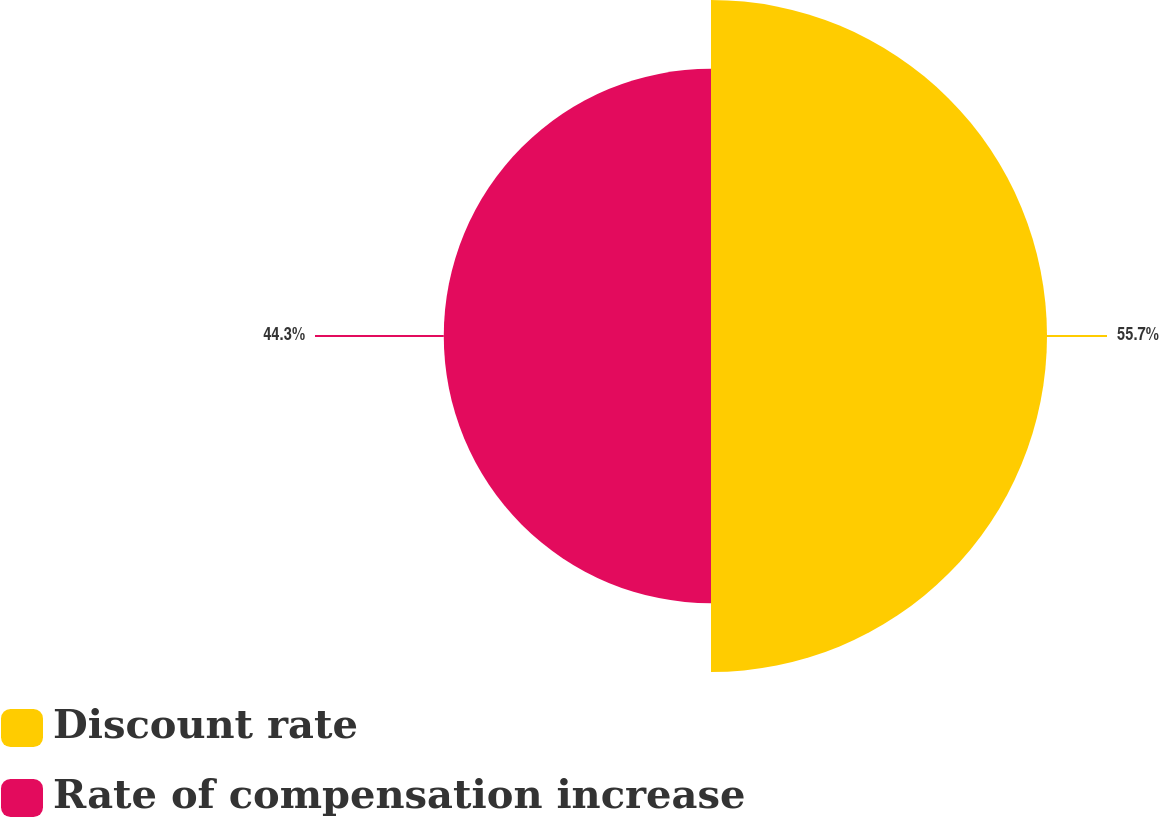<chart> <loc_0><loc_0><loc_500><loc_500><pie_chart><fcel>Discount rate<fcel>Rate of compensation increase<nl><fcel>55.7%<fcel>44.3%<nl></chart> 